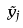<formula> <loc_0><loc_0><loc_500><loc_500>\tilde { y } _ { j }</formula> 